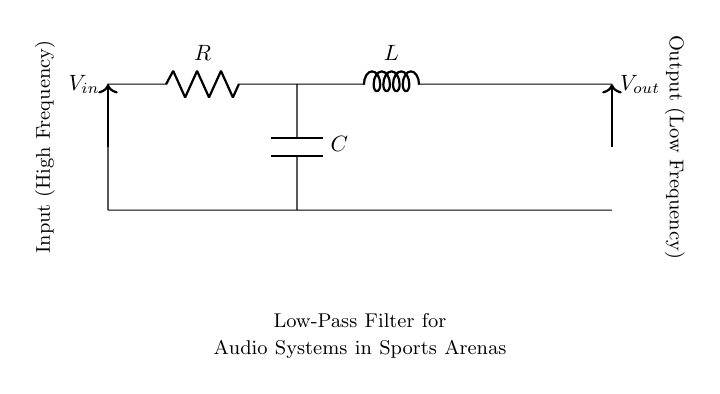What type of filter is this circuit implementing? The circuit implements a low-pass filter, which allows low-frequency signals to pass while attenuating high-frequency signals. This is evident from the placement of the resistor, inductor, and capacitor, designed to facilitate this behavior.
Answer: Low-pass filter What is the role of the capacitor in this circuit? The capacitor in a low-pass filter stores and releases energy, affecting how the circuit responds to different frequencies. It allows high-frequency signals to be bypassed to ground, reducing their amplitude at the output.
Answer: Attenuates high frequencies How many components are in this circuit? The circuit contains three components: a resistor, an inductor, and a capacitor. Each plays a unique role in shaping the frequency response of the circuit.
Answer: Three What happens to high-frequency signals at the output? High-frequency signals are significantly attenuated at the output due to the circuit's design and the behavior of the capacitor and inductor, which work together to block these frequencies.
Answer: They are attenuated What is the output voltage's dependency on frequency? The output voltage decreases as the input frequency increases, due to the filter's nature; this is characterized by the cutoff frequency, above which the output significantly drops.
Answer: Decreases with frequency What connection type is used between the components? The components are connected in series, which means the current flows through one component and then the next, maintaining a single path for electrical flow, characteristic of low-pass filters.
Answer: Series connection 